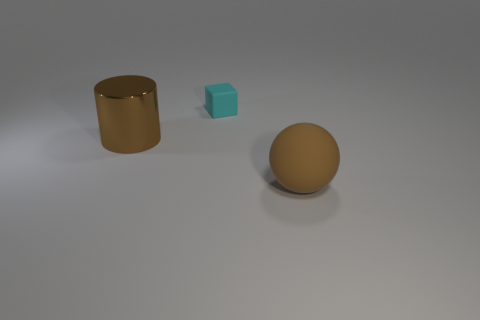Can you tell me what materials the objects in this image might be made of? The cylindrical object has a metallic sheen, suggesting it could be made of a metal or metal alloy. The cyan block and the sphere have a matte finish, indicating they could be made of plastic or a similarly textured material. 